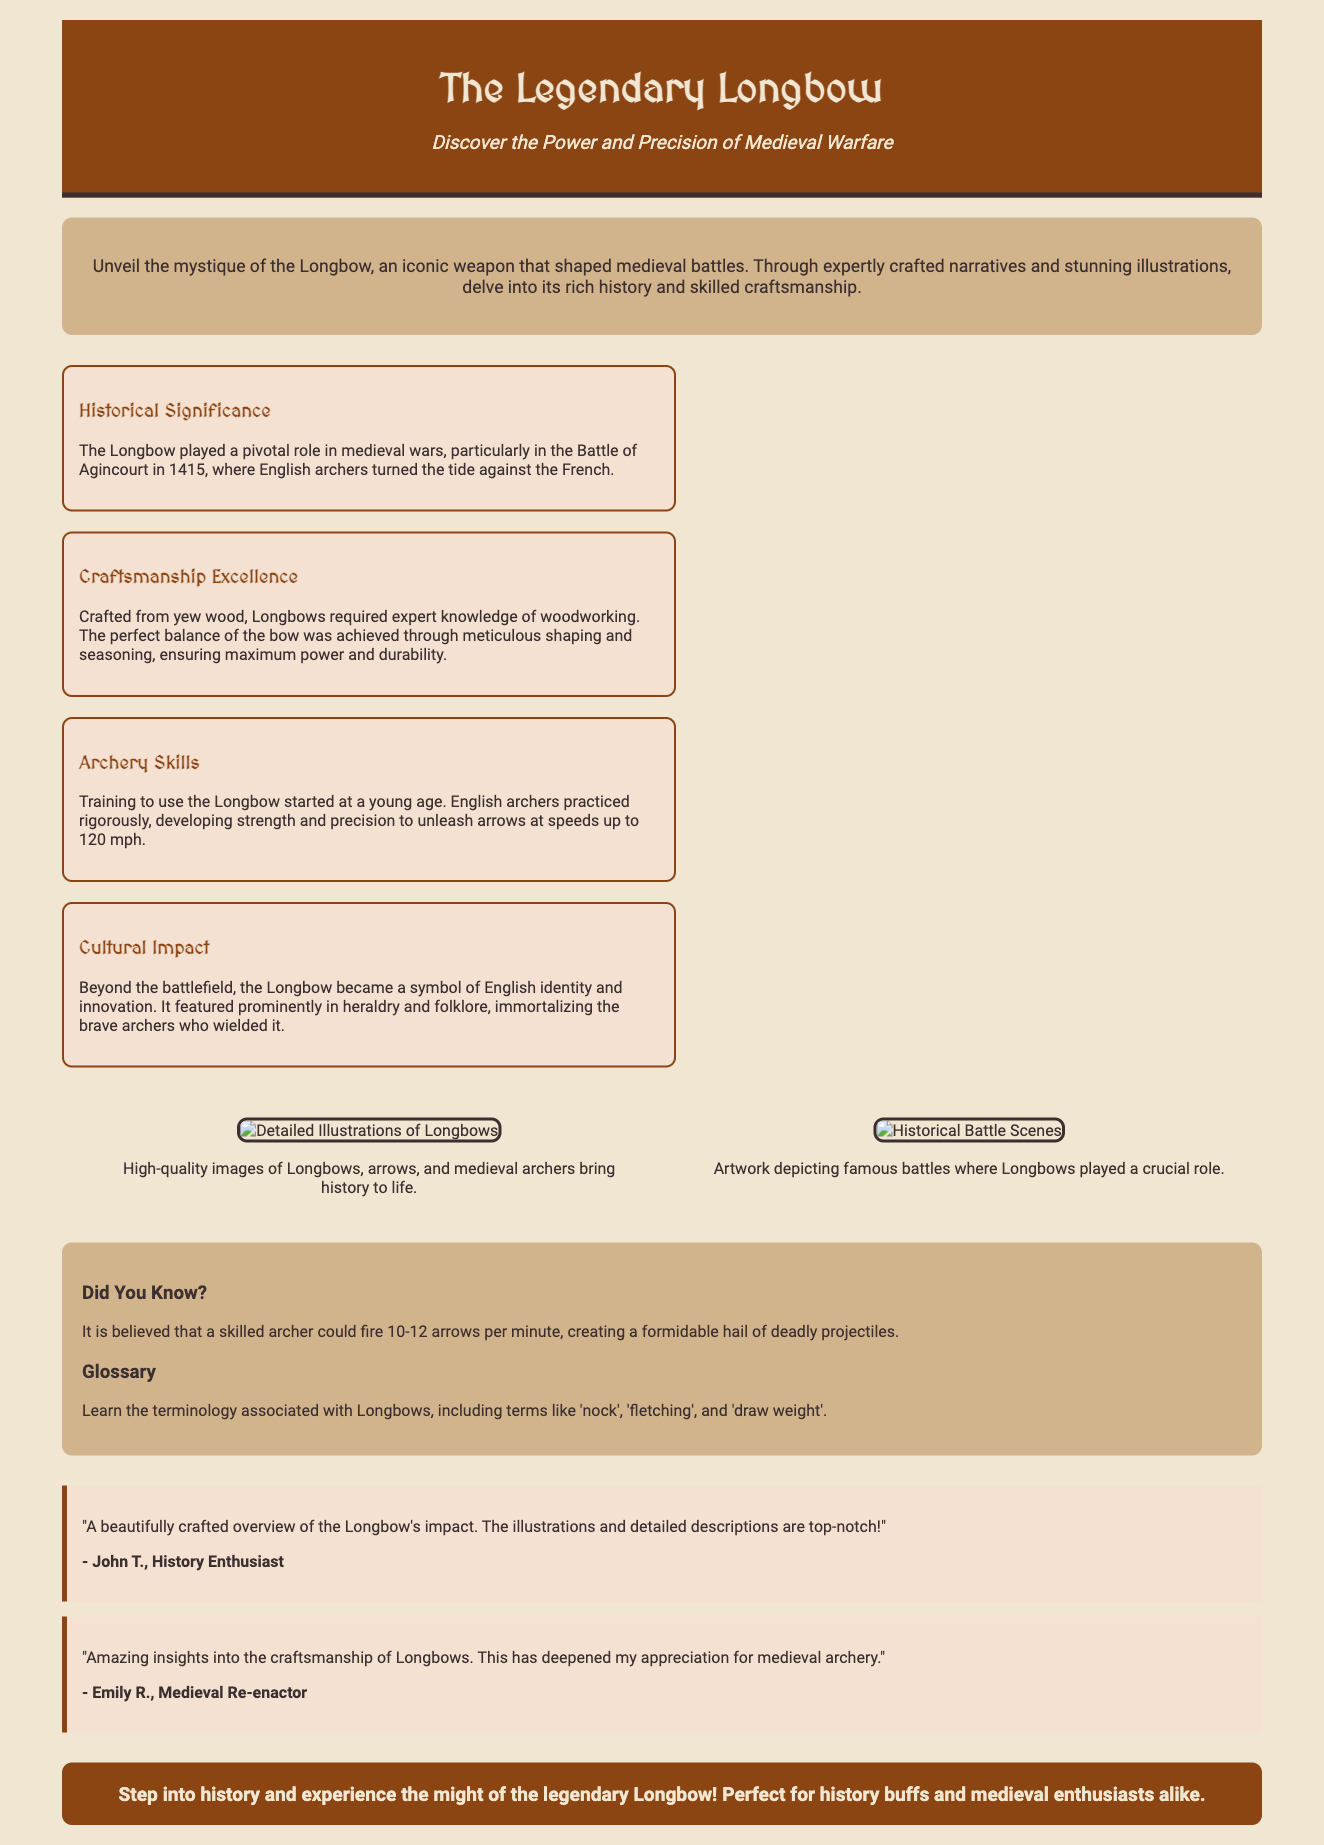What battle is highlighted in the document? The document mentions the Battle of Agincourt in 1415 as a pivotal moment for the Longbow.
Answer: Battle of Agincourt What material is primarily used to craft Longbows? The document states that Longbows are crafted primarily from yew wood.
Answer: Yew wood How many arrows could a skilled archer fire per minute? The document indicates that a skilled archer could fire 10-12 arrows per minute.
Answer: 10-12 arrows What is one aspect of the Longbow's cultural impact? The Longbow became a symbol of English identity and is featured in heraldry and folklore.
Answer: Symbol of English identity What important skill must archers develop for using the Longbow? Archers must develop strength and precision to effectively use the Longbow.
Answer: Strength and precision What does the document say about Longbow illustrations? The document states that high-quality images of Longbows and archers bring history to life.
Answer: High-quality images What is the main focus of the product packaging? The focus is on the history and craftsmanship of the Legendary Longbow.
Answer: History and craftsmanship What review highlights the document's illustrations? A review by John T. mentions the top-notch illustrations and detailed descriptions.
Answer: "The illustrations and detailed descriptions are top-notch!" 